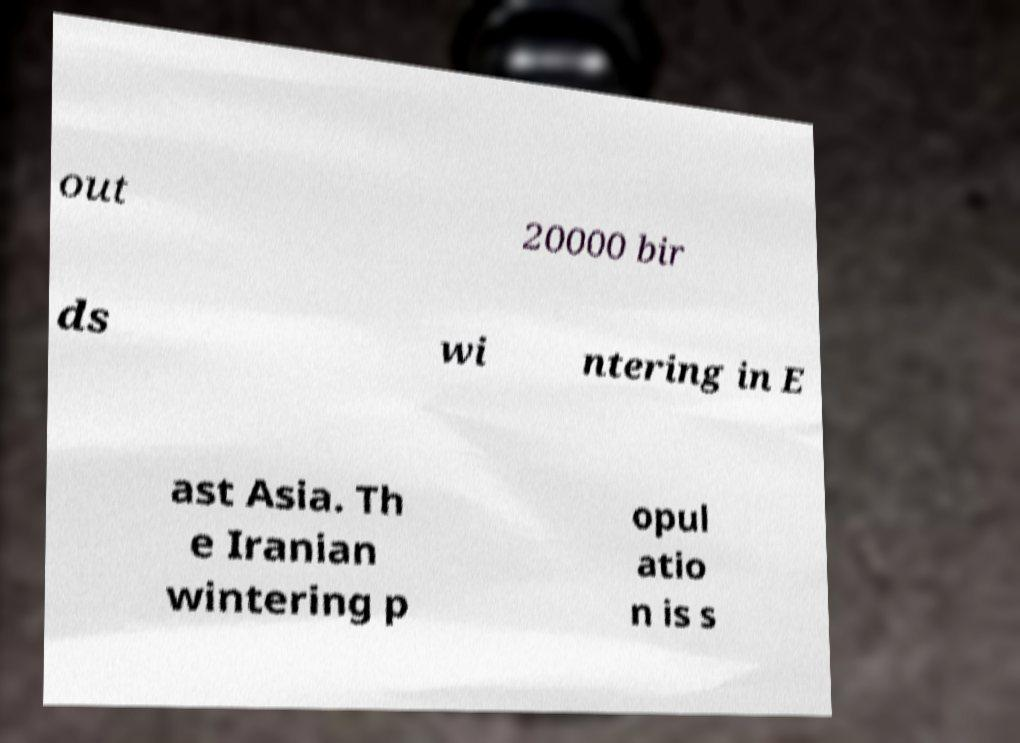Please read and relay the text visible in this image. What does it say? out 20000 bir ds wi ntering in E ast Asia. Th e Iranian wintering p opul atio n is s 